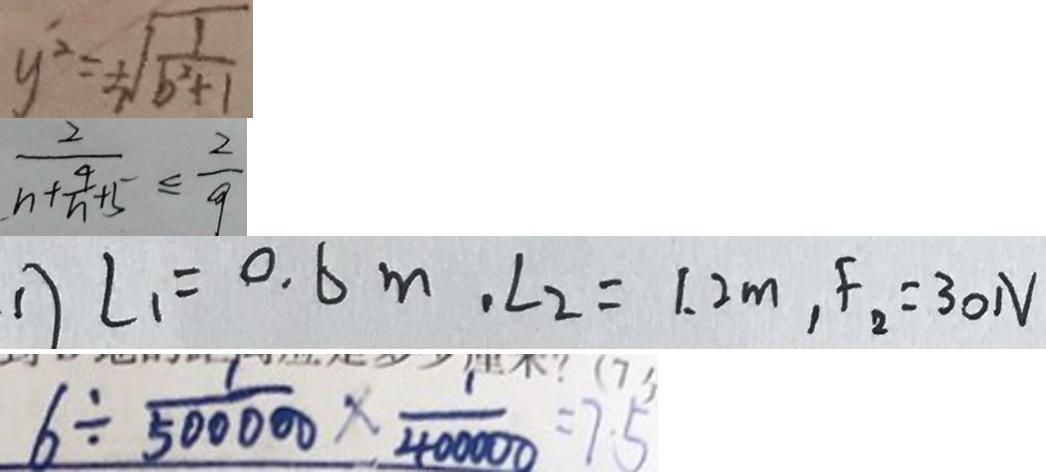Convert formula to latex. <formula><loc_0><loc_0><loc_500><loc_500>y ^ { 2 } = \sqrt { \frac { 1 } { b ^ { 2 } + 1 } } 
 \frac { 2 } { n + \frac { 4 } { n } + 5 } \leq \frac { 2 } { 9 } 
 1 ) \angle 1 = 0 . 6 m , \angle 2 = 1 . 2 m , F _ { 2 } = 3 0 N 
 6 \div \frac { 1 } { 5 0 0 0 0 0 } \times \frac { 1 } { 4 0 0 0 0 0 } = 7 5</formula> 